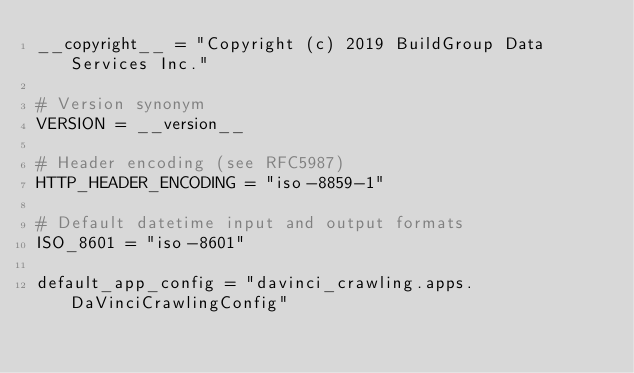<code> <loc_0><loc_0><loc_500><loc_500><_Python_>__copyright__ = "Copyright (c) 2019 BuildGroup Data Services Inc."

# Version synonym
VERSION = __version__

# Header encoding (see RFC5987)
HTTP_HEADER_ENCODING = "iso-8859-1"

# Default datetime input and output formats
ISO_8601 = "iso-8601"

default_app_config = "davinci_crawling.apps.DaVinciCrawlingConfig"
</code> 